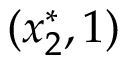<formula> <loc_0><loc_0><loc_500><loc_500>( x _ { 2 } ^ { * } , 1 )</formula> 